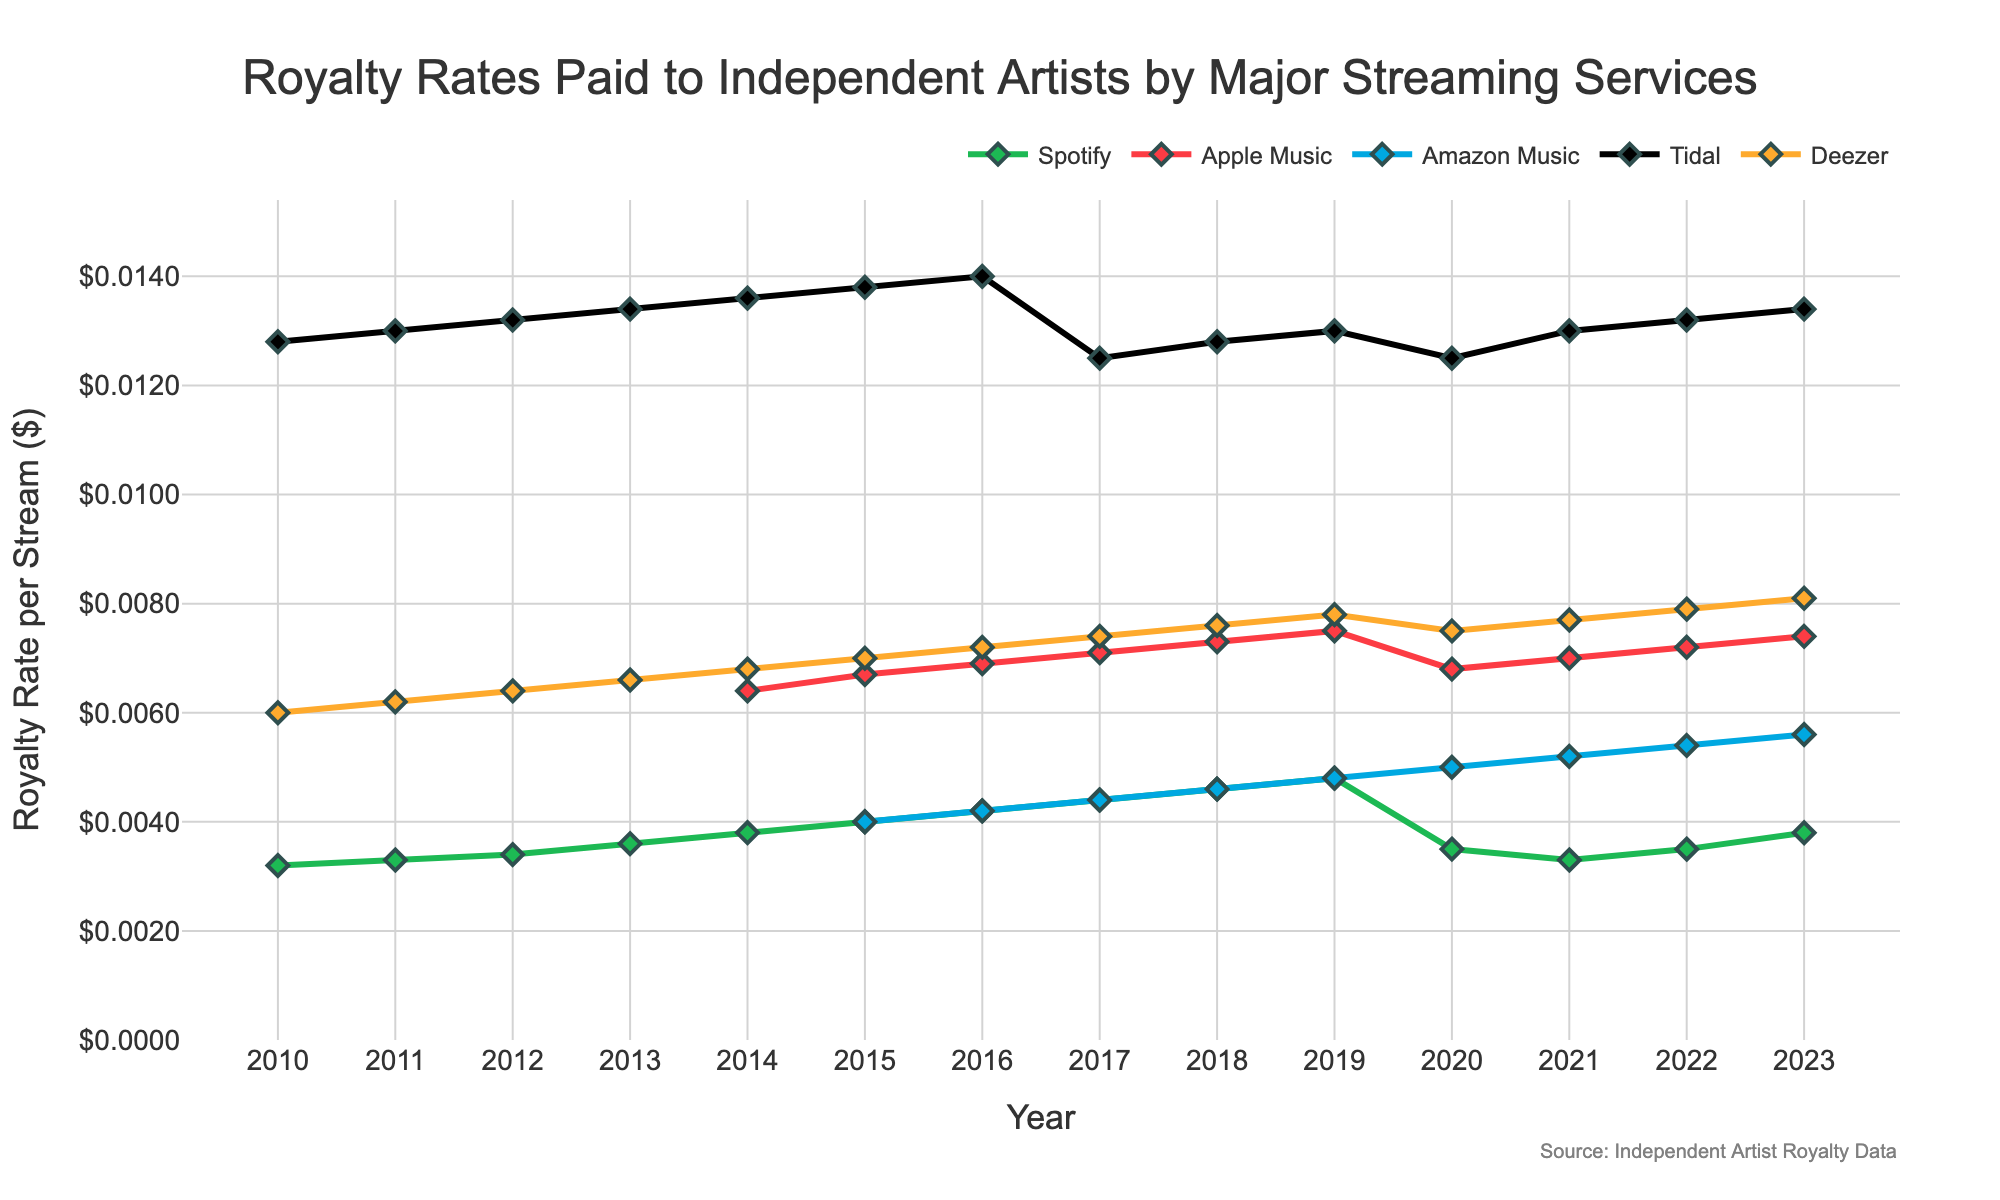How has Spotify's royalty rate changed from 2010 to 2023? The figure shows that Spotify's royalty rate started at $0.0032 in 2010 and increased to $0.0048 by 2019. However, it decreased to $0.0033 in 2021 before rising back to $0.0038 in 2023.
Answer: It increased initially, then slightly decreased, but ended with an overall increase When did Apple Music start paying royalties, and what was the initial rate? Apple Music is absent from the dataset until 2014, with the initial rate being $0.0064 in that year.
Answer: 2014, $0.0064 Which streaming service consistently paid the highest royalty rates over the years? The figure indicates that Tidal has consistently paid the highest royalty rates from 2010 to 2023, maintaining rates around $0.0125 to $0.014.
Answer: Tidal How does Deezer’s royalty rate in 2023 compare to its rate in 2010? Deezer's rate in 2010 was $0.006, which gradually increased to $0.0081 by 2023.
Answer: It increased Among Spotify, Apple Music, and Amazon Music, which service had the greatest rate of increase in its royalty rate between 2010 and 2019? To compare, we observe the initial and final rates for these years: 
- Spotify: $0.0032 to $0.0048 (increased by $0.0016)
- Apple Music: Data available only from 2014 at $0.0064 to $0.0075 (increased by $0.0011)
- Amazon Music: Data available only from 2015 at $0.004 to $0.0048 (increased by $0.0008) 
Spotify had the greatest increase at $0.0016.
Answer: Spotify Which year did Amazon Music start paying royalties, and what has been the general trend since then? Amazon Music appears in the figure starting from 2015 with a rate of $0.004, and it has generally increased over the years to $0.0056 in 2023.
Answer: 2015, increasing trend By how much did Deezer’s royalty rate increase from 2020 to 2023? Deezer's rate was $0.0075 in 2020, which increased to $0.0081 in 2023. The increase is $0.0081 - $0.0075 = $0.0006.
Answer: $0.0006 Which streaming service had a decline in royalty rates around 2020? The figure shows that both Spotify and Tidal experienced a decline in royalty rates around 2020.
Answer: Spotify and Tidal How does the 2023 royalty rate for Amazon Music compare to that for Deezer? In 2023, Amazon Music pays $0.0056 per stream, while Deezer pays $0.0081 per stream. Deezer's rate is higher than Amazon Music's.
Answer: Deezer’s rate is higher What is the difference between Tidal's highest and lowest royalty rates over the time period? Tidal's highest rate is $0.014 in 2016, and its lowest rate is $0.0125 in 2017 and 2020. The difference is $0.014 - $0.0125 = $0.0015.
Answer: $0.0015 